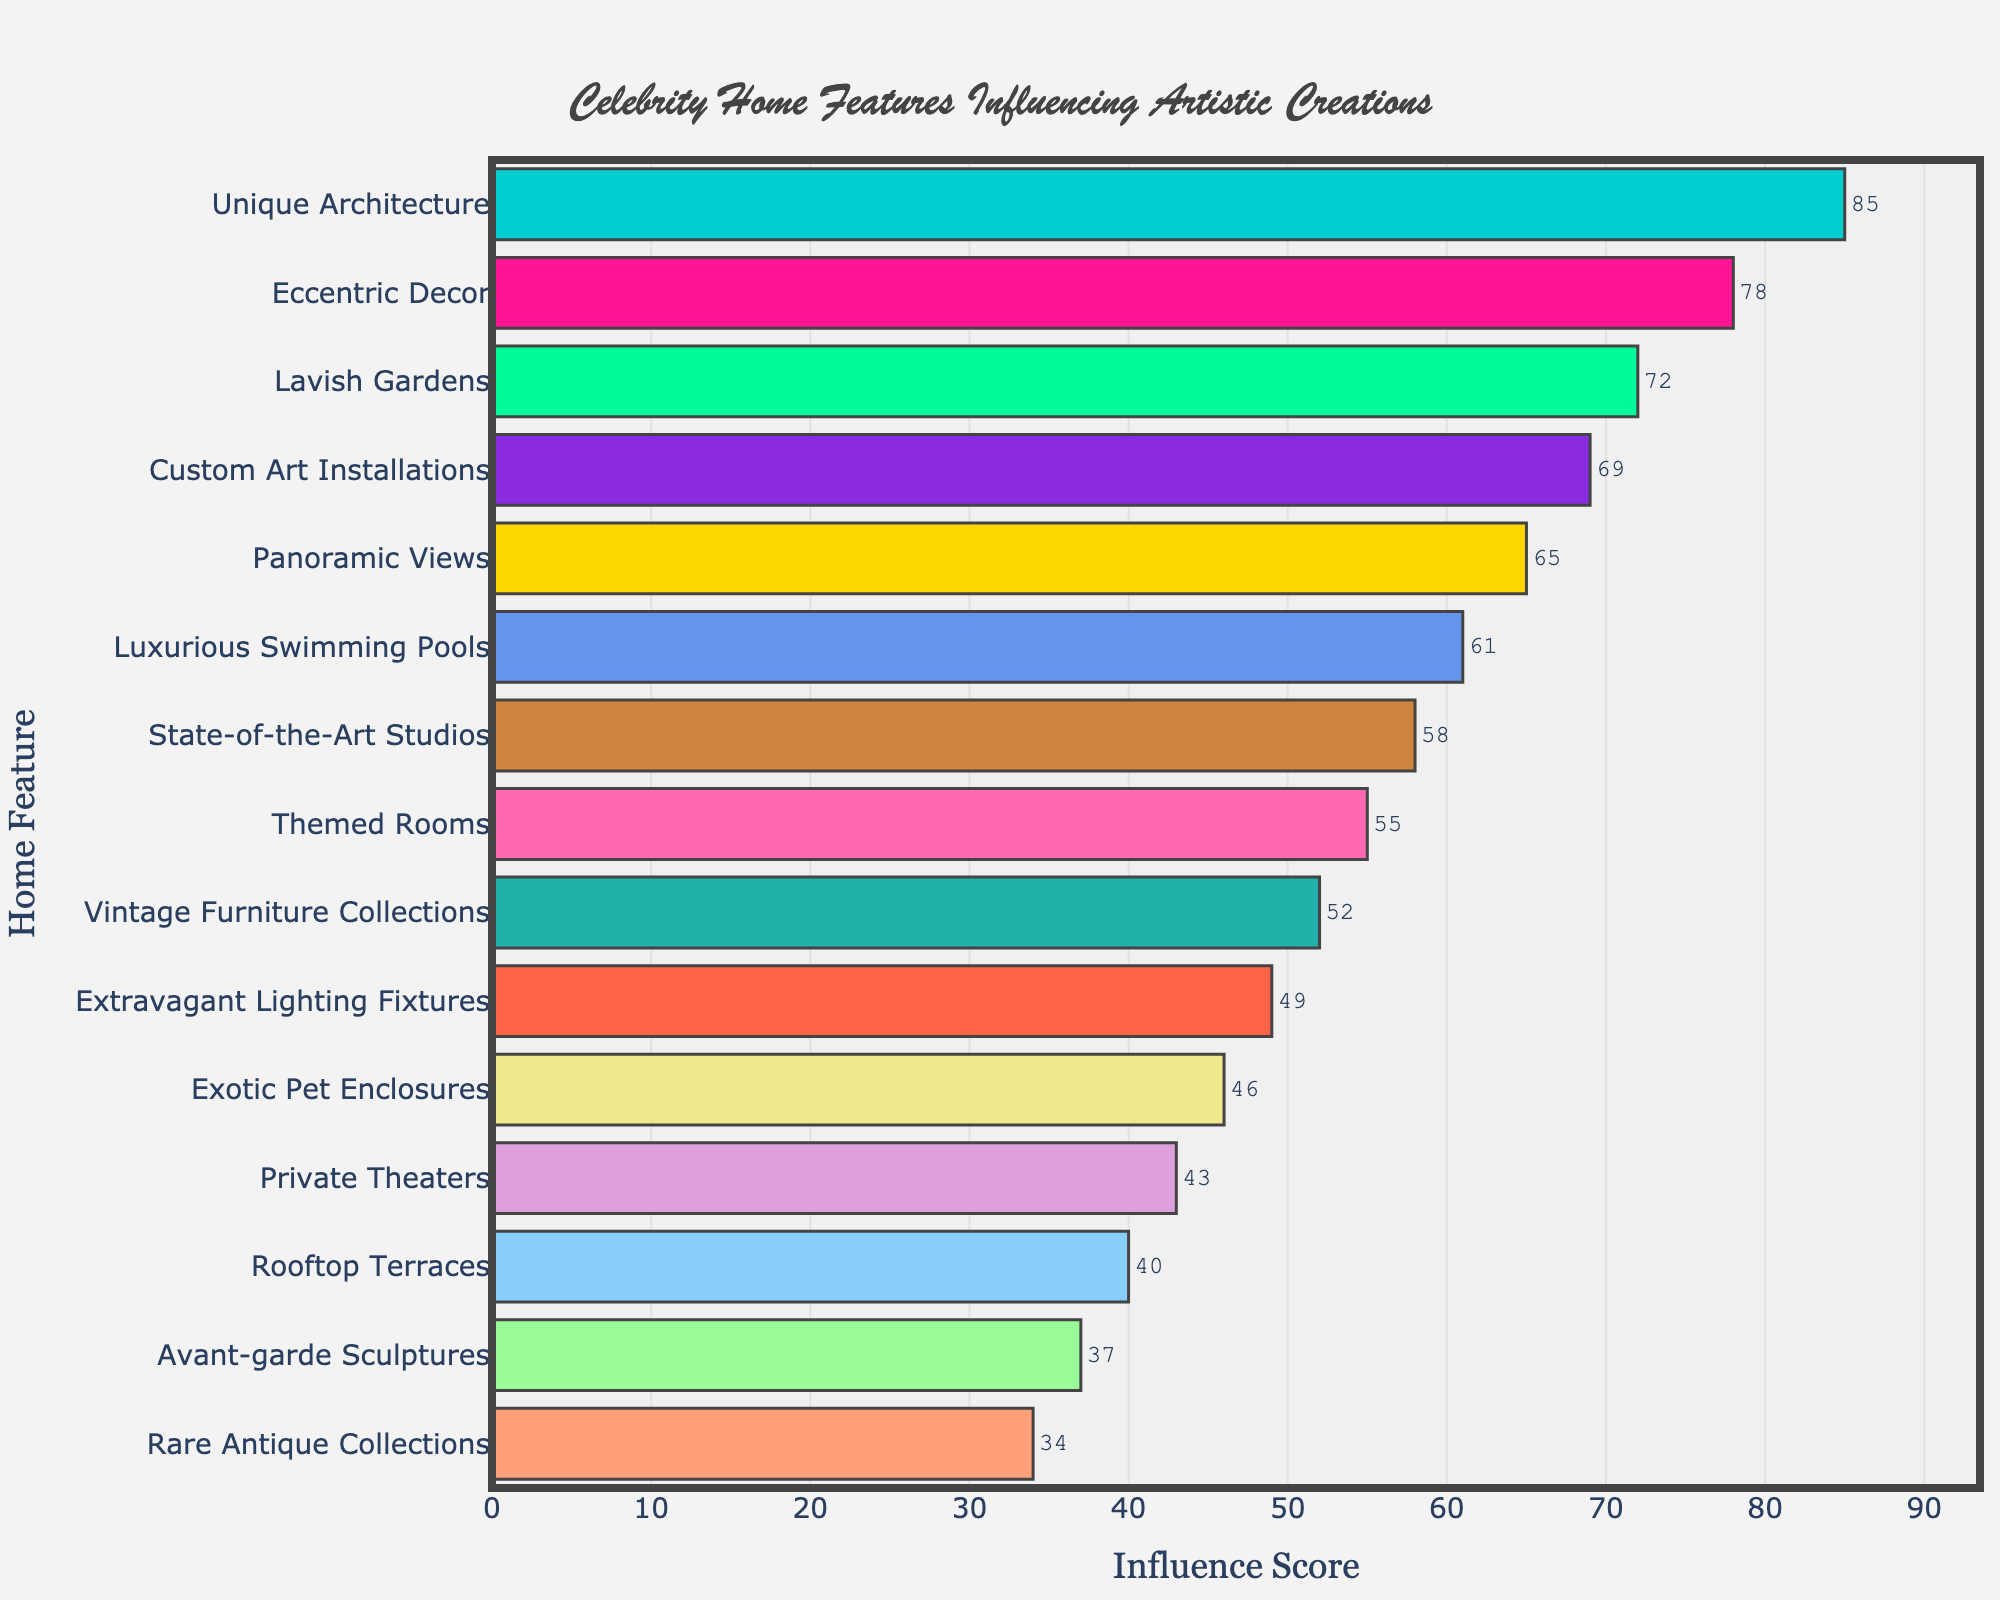What's the most influential feature in celebrity homes that inspires artistic creations? The feature with the highest influence score is the most influential one. According to the bar chart, "Unique Architecture" has the highest score.
Answer: Unique Architecture Which feature has the least influence on artistic creations, and what is its score? The feature with the lowest influence score is at the bottom of the bar chart. This feature is "Rare Antique Collections" with a score of 34.
Answer: Rare Antique Collections, 34 How much more influential is "Unique Architecture" compared to "Rare Antique Collections"? To find the difference, subtract the influence score of "Rare Antique Collections" from "Unique Architecture". The calculation is 85 - 34 = 51.
Answer: 51 Compare the influence scores of "Lavish Gardens" and "Custom Art Installations". Which is higher and by how much? "Lavish Gardens" has an influence score of 72, while "Custom Art Installations" has an influence score of 69. The difference is 72 - 69 = 3. Therefore, "Lavish Gardens" is higher by 3 points.
Answer: Lavish Gardens, 3 What is the combined influence score of the top three most influential features? The top three features are "Unique Architecture" (85), "Eccentric Decor" (78), and "Lavish Gardens" (72). The combined score is 85 + 78 + 72 = 235.
Answer: 235 What is the average influence score of the features shown in the chart? To find the average, sum all the influence scores and divide by the number of features. The total sum is 85 + 78 + 72 + 69 + 65 + 61 + 58 + 55 + 52 + 49 + 46 + 43 + 40 + 37 + 34 = 844. There are 15 features, so the average is 844 / 15 ≈ 56.27.
Answer: 56.27 Which feature is directly in the middle of the list when the features are ordered by their influence scores? When ordered, the feature in the middle is the 8th one. Starting from the bottom (34) to the top (85), the feature in the 8th place is "Themed Rooms".
Answer: Themed Rooms Are "Luxurious Swimming Pools" more influential than "State-of-the-Art Studios"? "Luxurious Swimming Pools" has an influence score of 61, while "State-of-the-Art Studios" has a score of 58. Since 61 > 58, "Luxurious Swimming Pools" are more influential.
Answer: Yes 